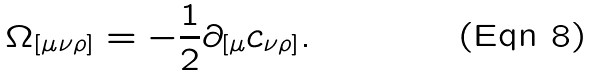Convert formula to latex. <formula><loc_0><loc_0><loc_500><loc_500>\Omega _ { [ \mu \nu \rho ] } = - \frac { 1 } { 2 } \partial _ { [ \mu } c _ { \nu \rho ] } .</formula> 